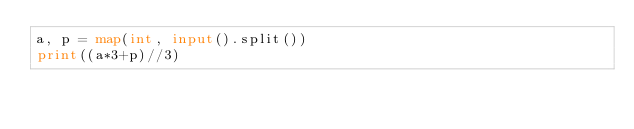<code> <loc_0><loc_0><loc_500><loc_500><_Python_>a, p = map(int, input().split())
print((a*3+p)//3)</code> 